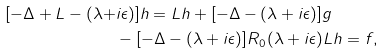Convert formula to latex. <formula><loc_0><loc_0><loc_500><loc_500>[ - \Delta + L - ( \lambda + & i \epsilon ) ] h = L h + [ - \Delta - ( \lambda + i \epsilon ) ] g \\ & - [ - \Delta - ( \lambda + i \epsilon ) ] R _ { 0 } ( \lambda + i \epsilon ) L h = f ,</formula> 